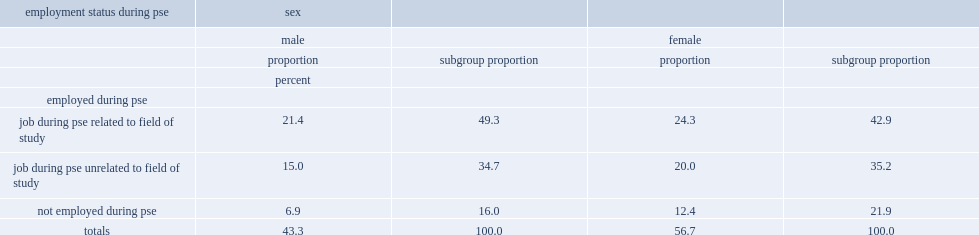What were the percentages of male graduates that had a job during their post-secondary education and their female counterparts respectively? 84 78.1. What were the percentages of males and females who had a job related to their field at some point during their pse respectively? 49.3 42.9. 